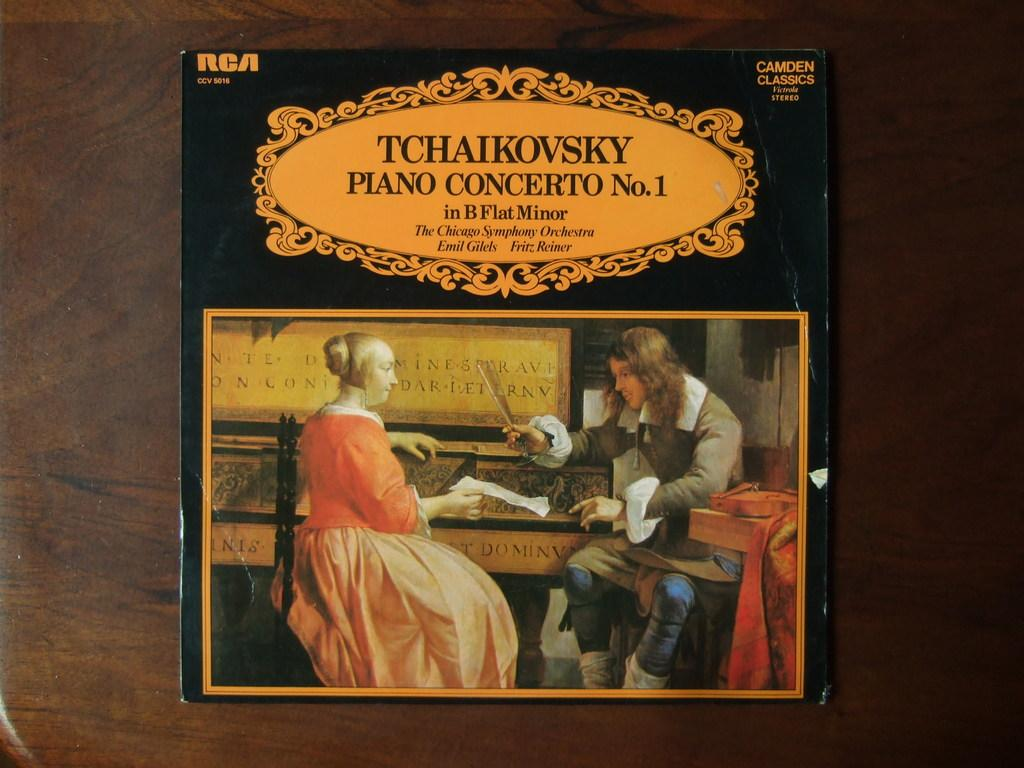<image>
Relay a brief, clear account of the picture shown. An old Tchaikovsky record of Piano Concerto No. 1. 